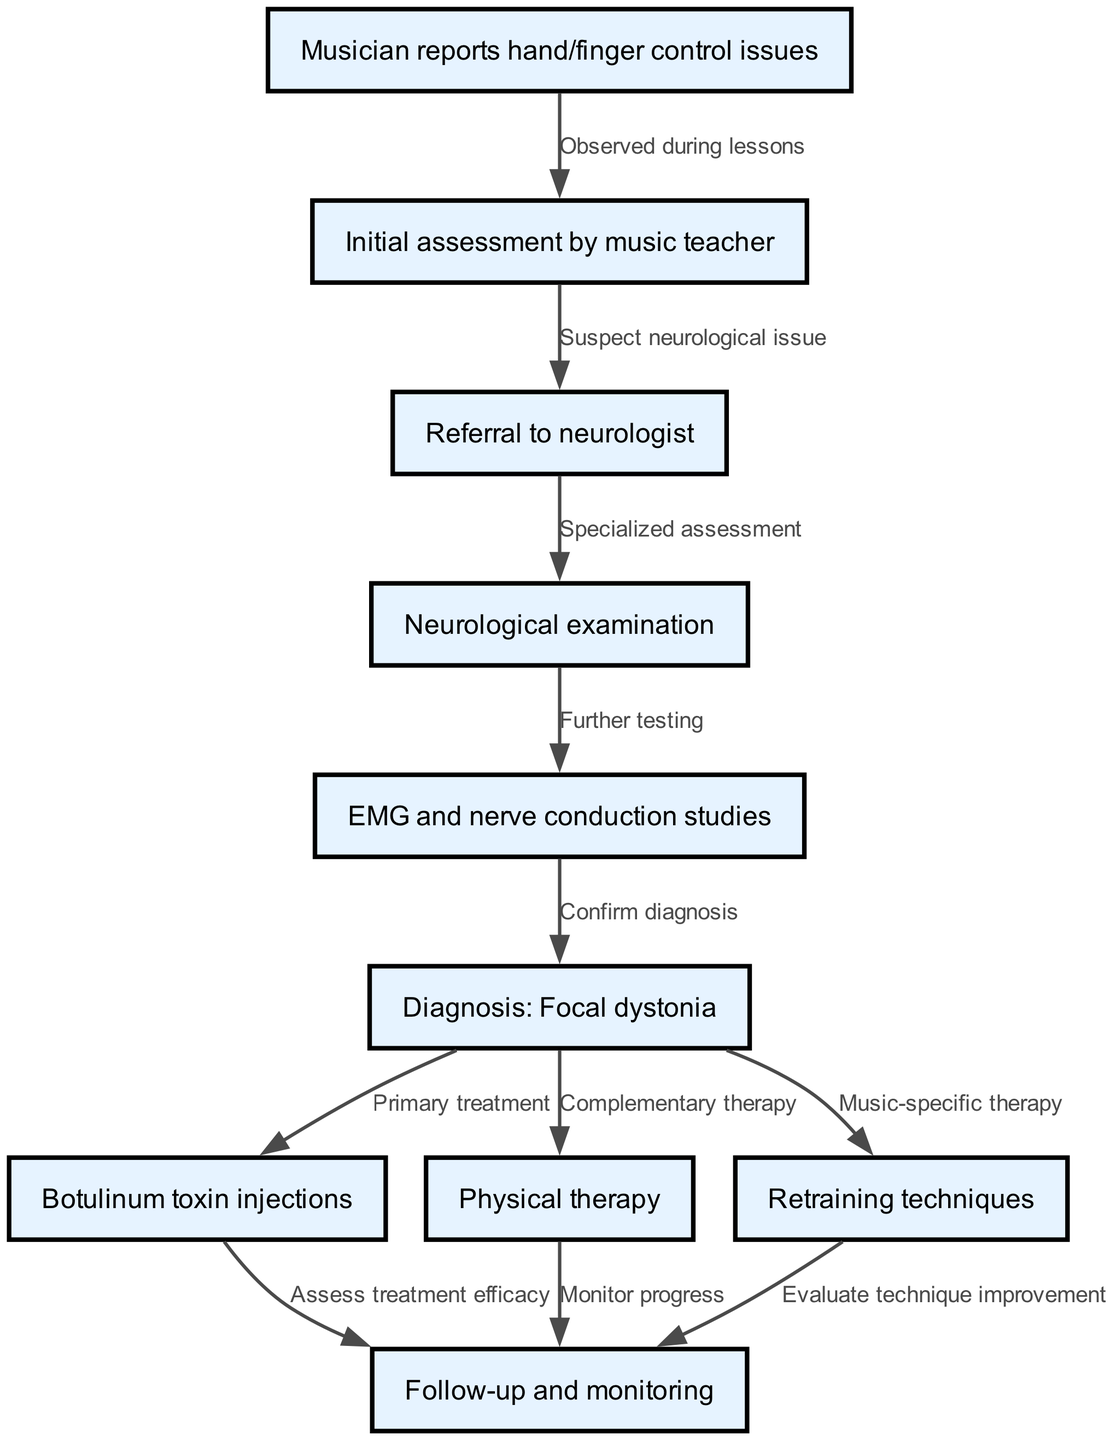What is the first step in the pathway? The first step, as indicated by the diagram, is when the "Musician reports hand/finger control issues". This is where the process of diagnosing musician’s focal dystonia begins.
Answer: Musician reports hand/finger control issues How many nodes are present in the diagram? The diagram consists of ten nodes that represent different steps in the clinical pathway for diagnosing and treating musician's focal dystonia.
Answer: Ten What type of examination follows the referral to the neurologist? After the referral to the neurologist, the next step is a "Neurological examination". This step focuses on assessing the musician for any neurological issues.
Answer: Neurological examination Which node represents the confirmation of diagnosis? The node that represents the confirmation of diagnosis is labeled "Diagnosis: Focal dystonia". This occurs after EMG and nerve conduction studies have been completed.
Answer: Diagnosis: Focal dystonia What is the primary treatment indicated in the pathway? The primary treatment indicated in the pathway is "Botulinum toxin injections". This is shown as a direct outcome from the confirmed diagnosis of focal dystonia.
Answer: Botulinum toxin injections What action occurs after the botulinum toxin injections? After the botulinum toxin injections, the next action is "Assess treatment efficacy". This step is crucial for evaluating whether the primary treatment is effective for the musician.
Answer: Assess treatment efficacy Which therapy is considered complementary to the primary treatment? "Physical therapy" is considered the complementary therapy in the treatment pathway for musician's focal dystonia, according to the diagram.
Answer: Physical therapy How are progress and technique improvements monitored after the treatments? The diagram shows that both "Monitor progress" and "Evaluate technique improvement" take place after physical therapy and retraining techniques, ensuring comprehensive follow-up on the musician's condition.
Answer: Monitor progress and Evaluate technique improvement Which step in the pathway indicates a specialized assessment by a neurologist? The step indicating a specialized assessment after the referral is marked as "Neurological examination", where detailed assessment of symptoms is performed.
Answer: Neurological examination 